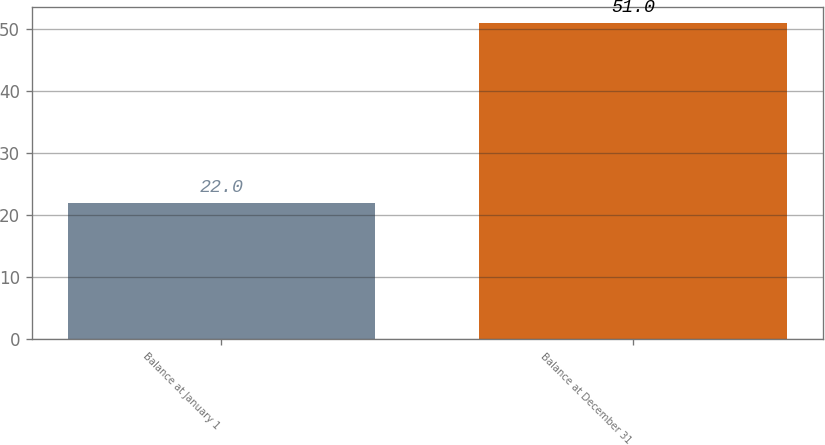Convert chart. <chart><loc_0><loc_0><loc_500><loc_500><bar_chart><fcel>Balance at January 1<fcel>Balance at December 31<nl><fcel>22<fcel>51<nl></chart> 